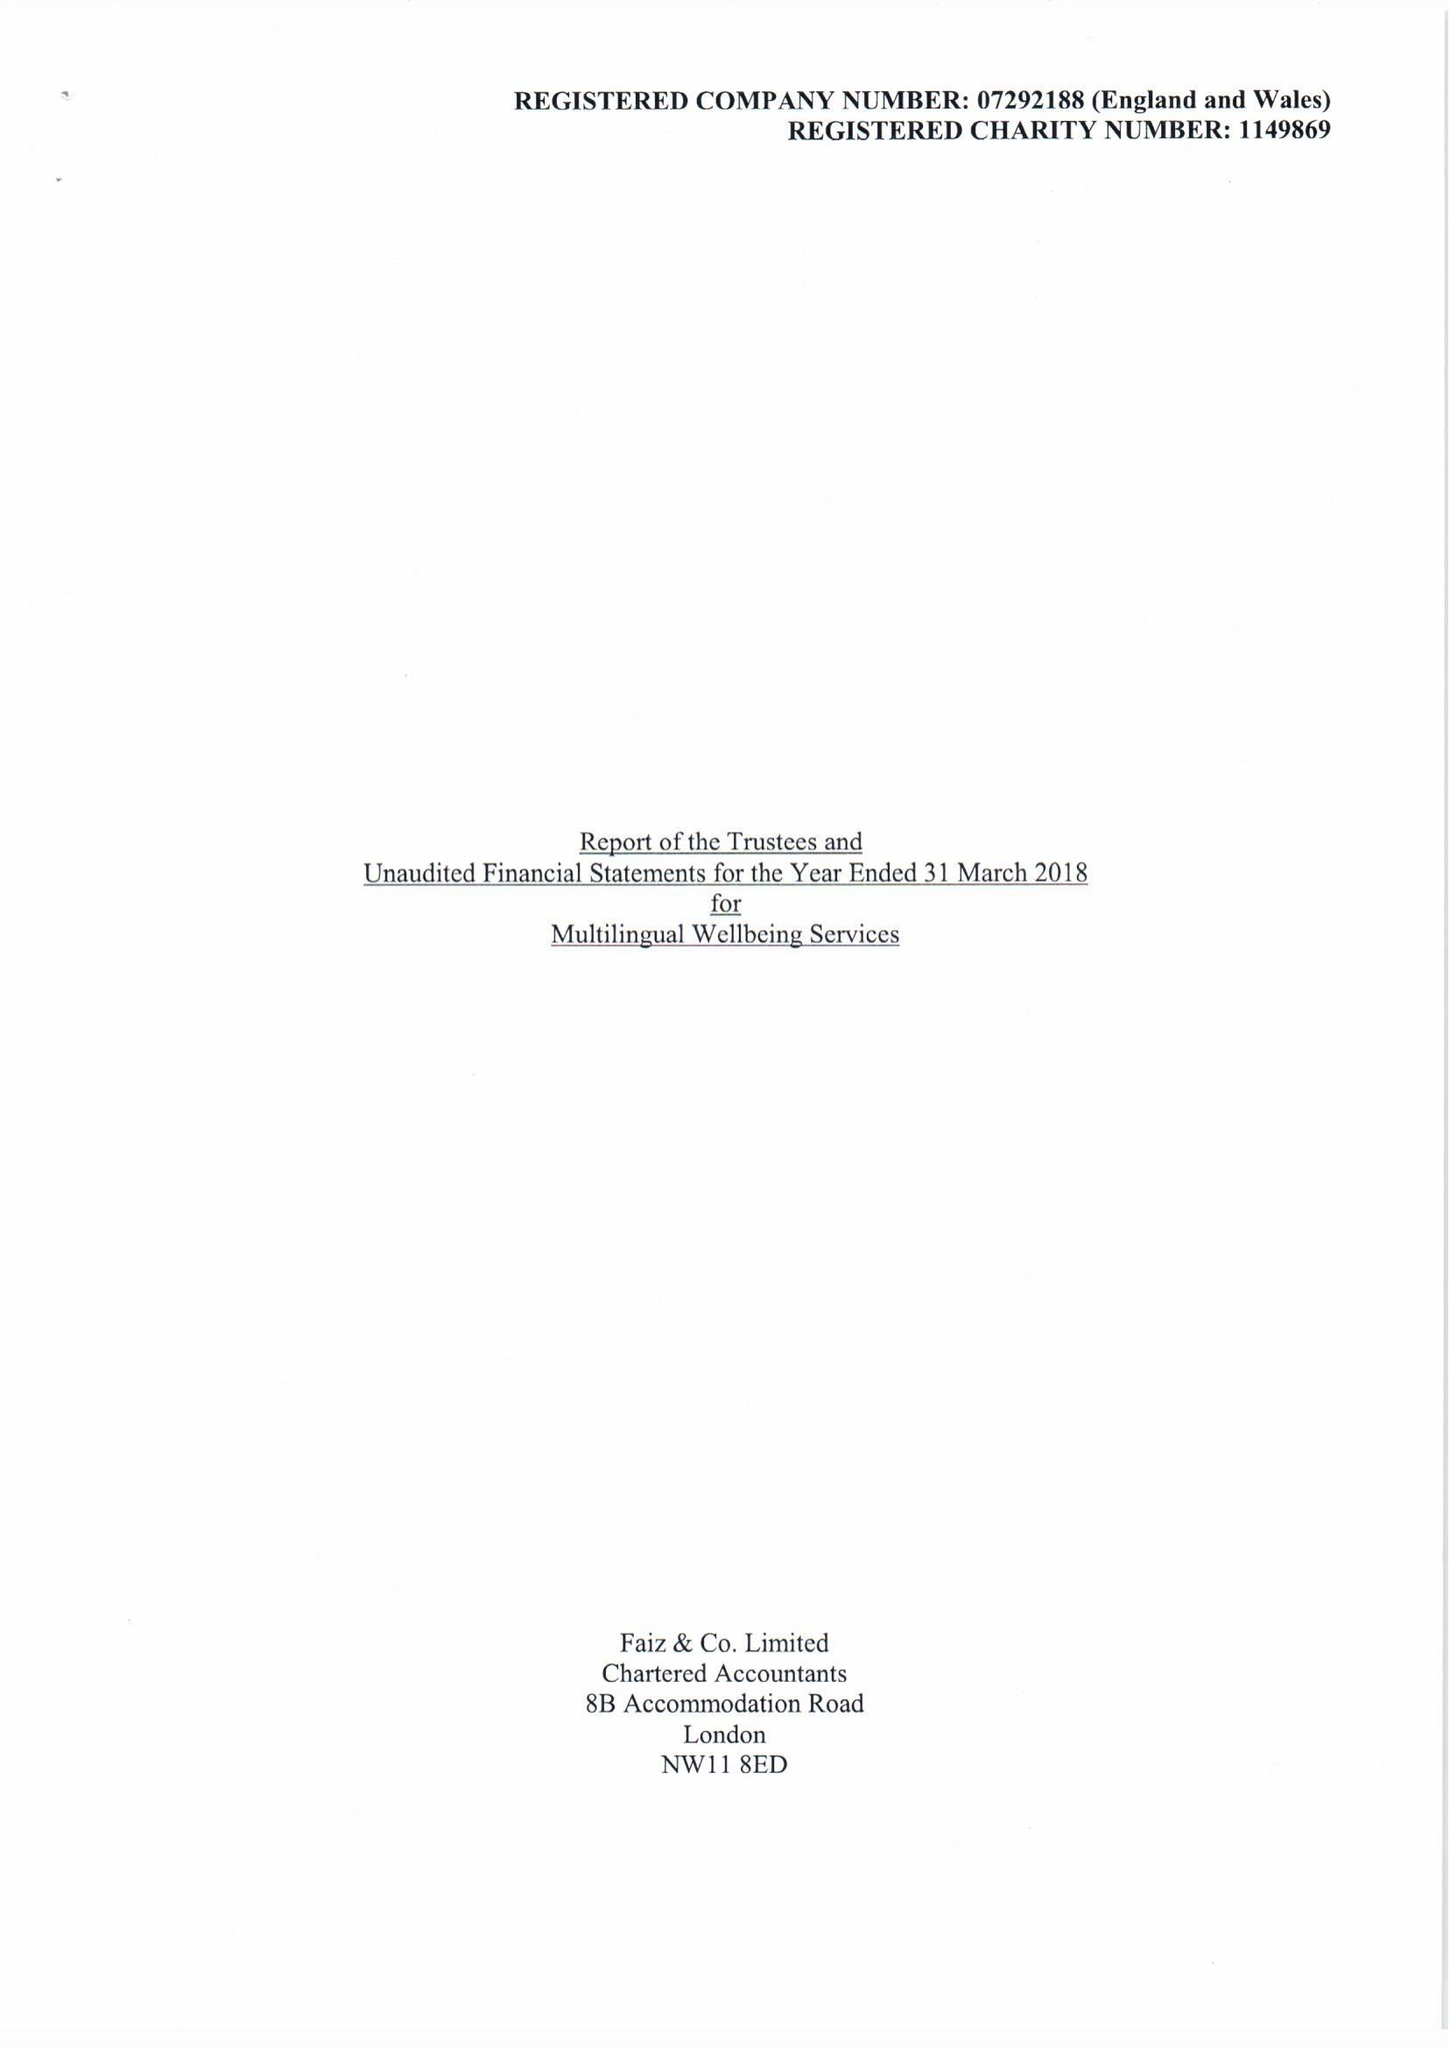What is the value for the spending_annually_in_british_pounds?
Answer the question using a single word or phrase. 208033.00 